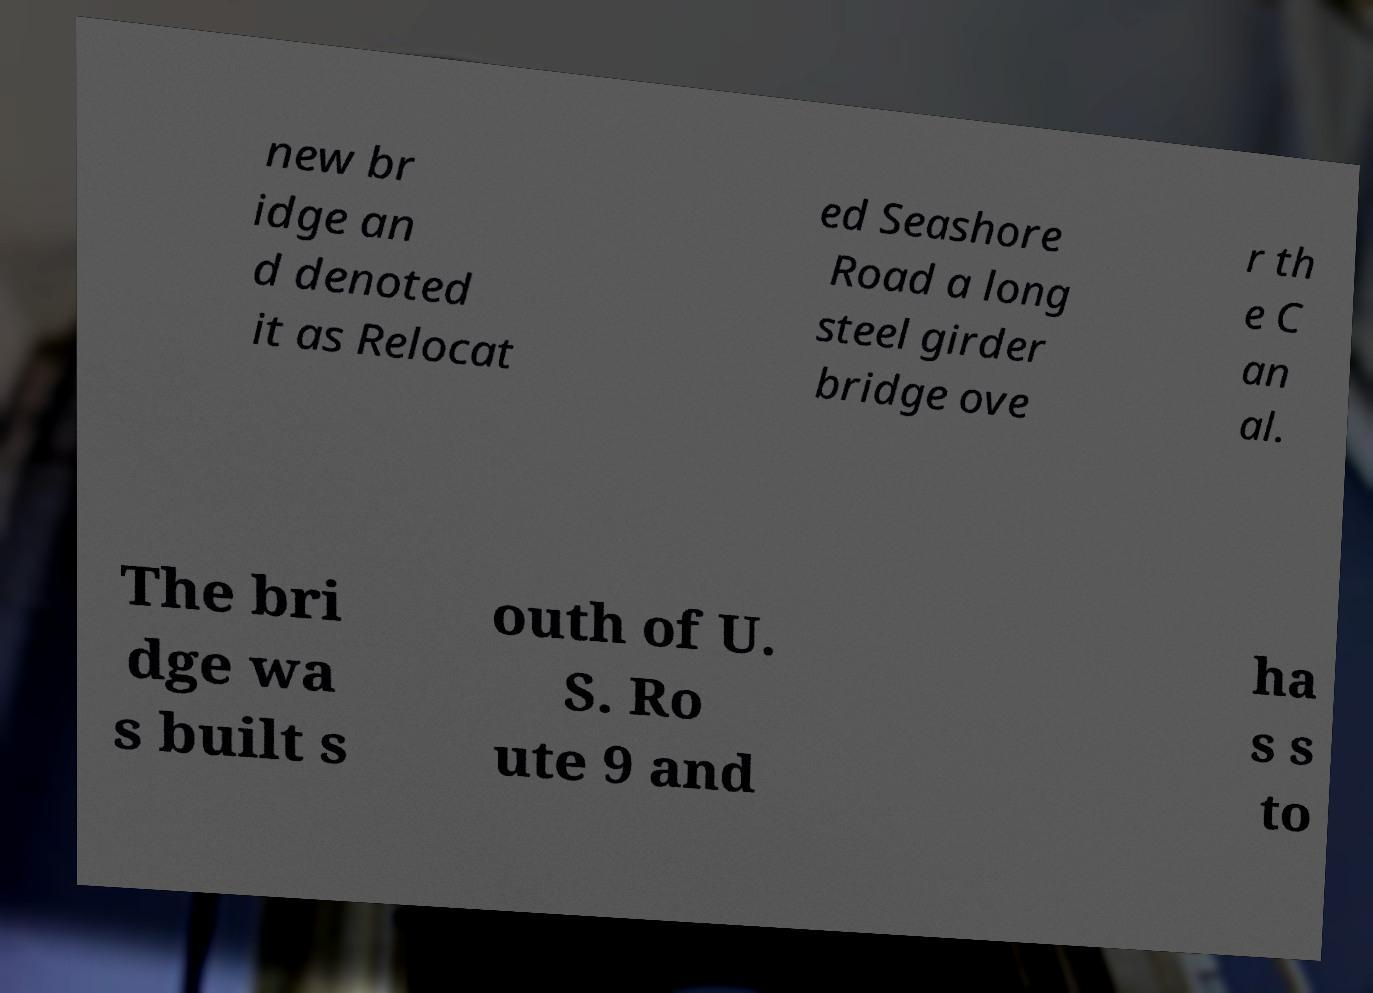Can you read and provide the text displayed in the image?This photo seems to have some interesting text. Can you extract and type it out for me? new br idge an d denoted it as Relocat ed Seashore Road a long steel girder bridge ove r th e C an al. The bri dge wa s built s outh of U. S. Ro ute 9 and ha s s to 